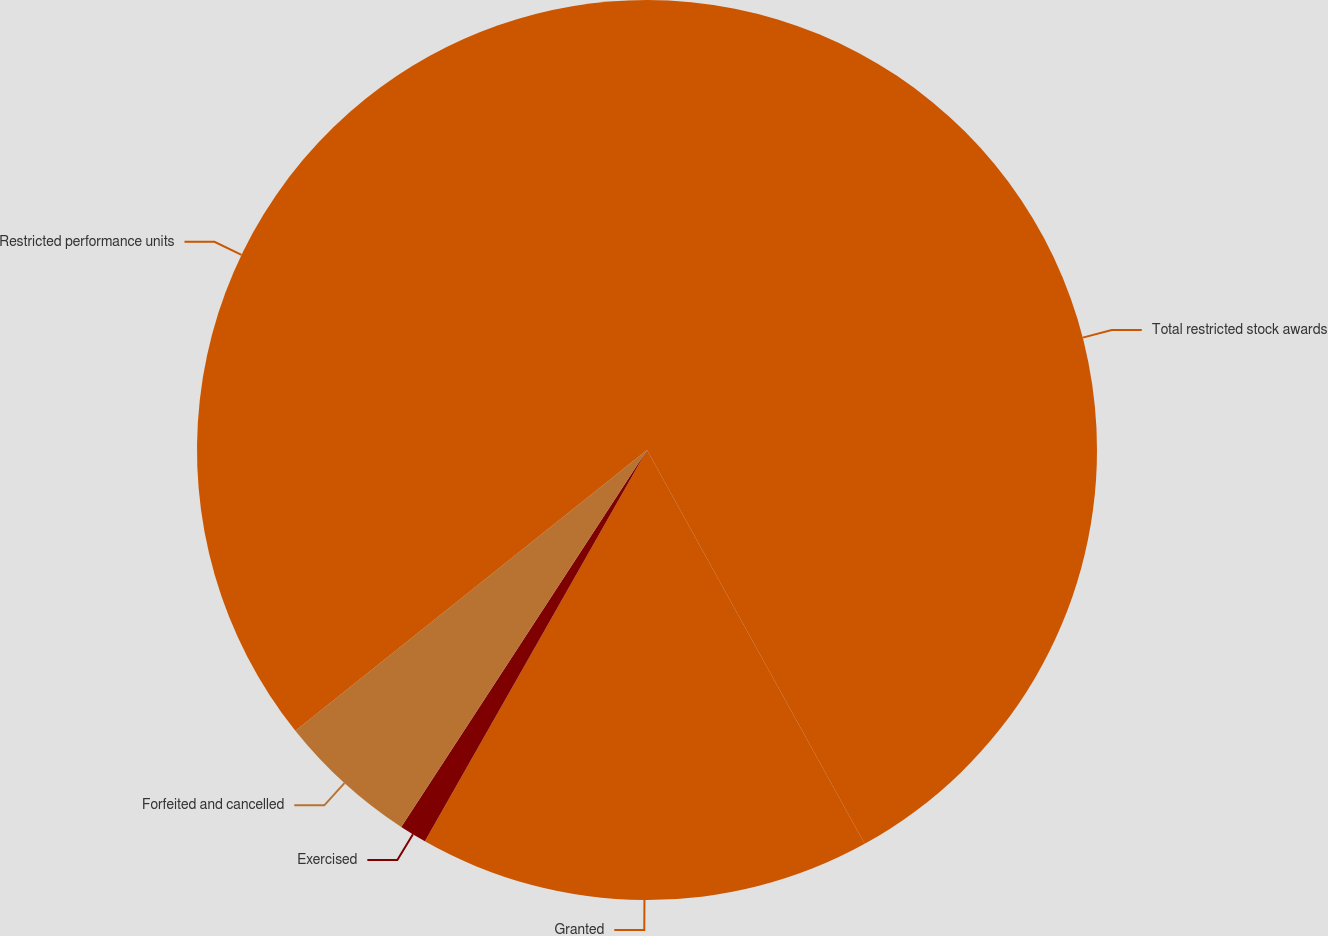<chart> <loc_0><loc_0><loc_500><loc_500><pie_chart><fcel>Total restricted stock awards<fcel>Granted<fcel>Exercised<fcel>Forfeited and cancelled<fcel>Restricted performance units<nl><fcel>41.96%<fcel>16.25%<fcel>0.98%<fcel>5.08%<fcel>35.72%<nl></chart> 